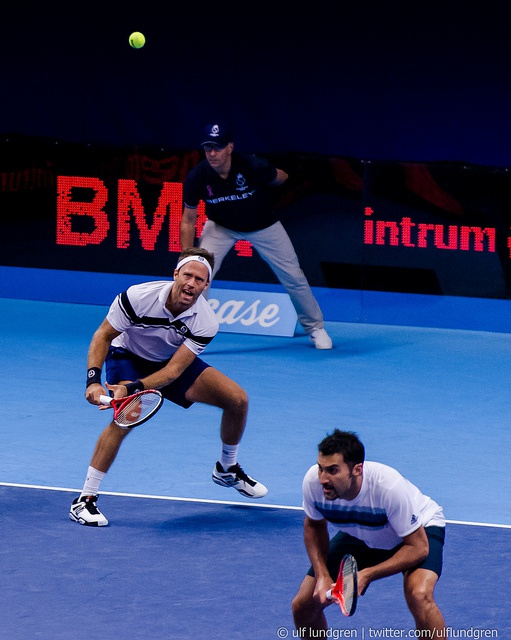Describe the objects in this image and their specific colors. I can see people in black, gray, brown, and lavender tones, people in black, brown, darkgray, and lavender tones, tennis racket in black, gray, brown, and maroon tones, tennis racket in black, darkgray, gray, and lightpink tones, and sports ball in black, khaki, lightgreen, and olive tones in this image. 